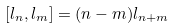<formula> <loc_0><loc_0><loc_500><loc_500>[ l _ { n } , l _ { m } ] = ( n - m ) l _ { n + m }</formula> 